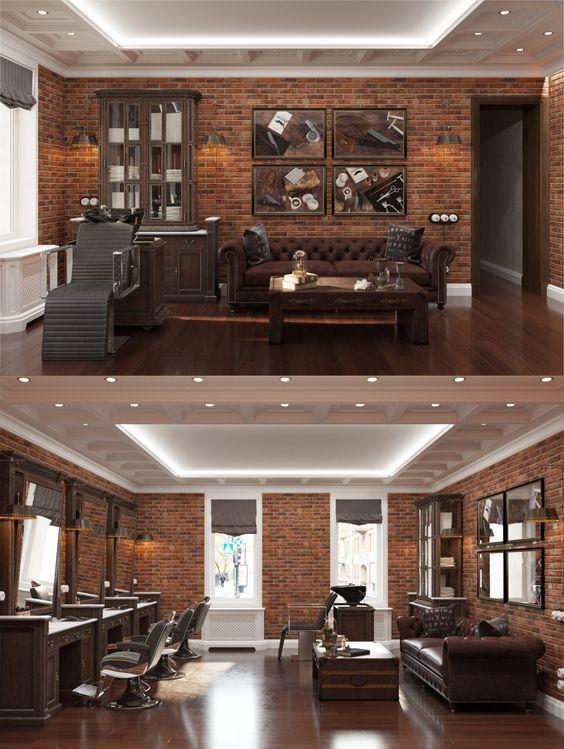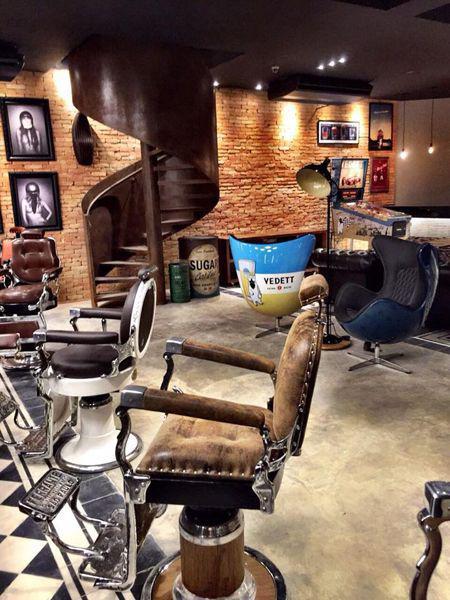The first image is the image on the left, the second image is the image on the right. Assess this claim about the two images: "The decor in one image features black surfaces predominantly.". Correct or not? Answer yes or no. No. 